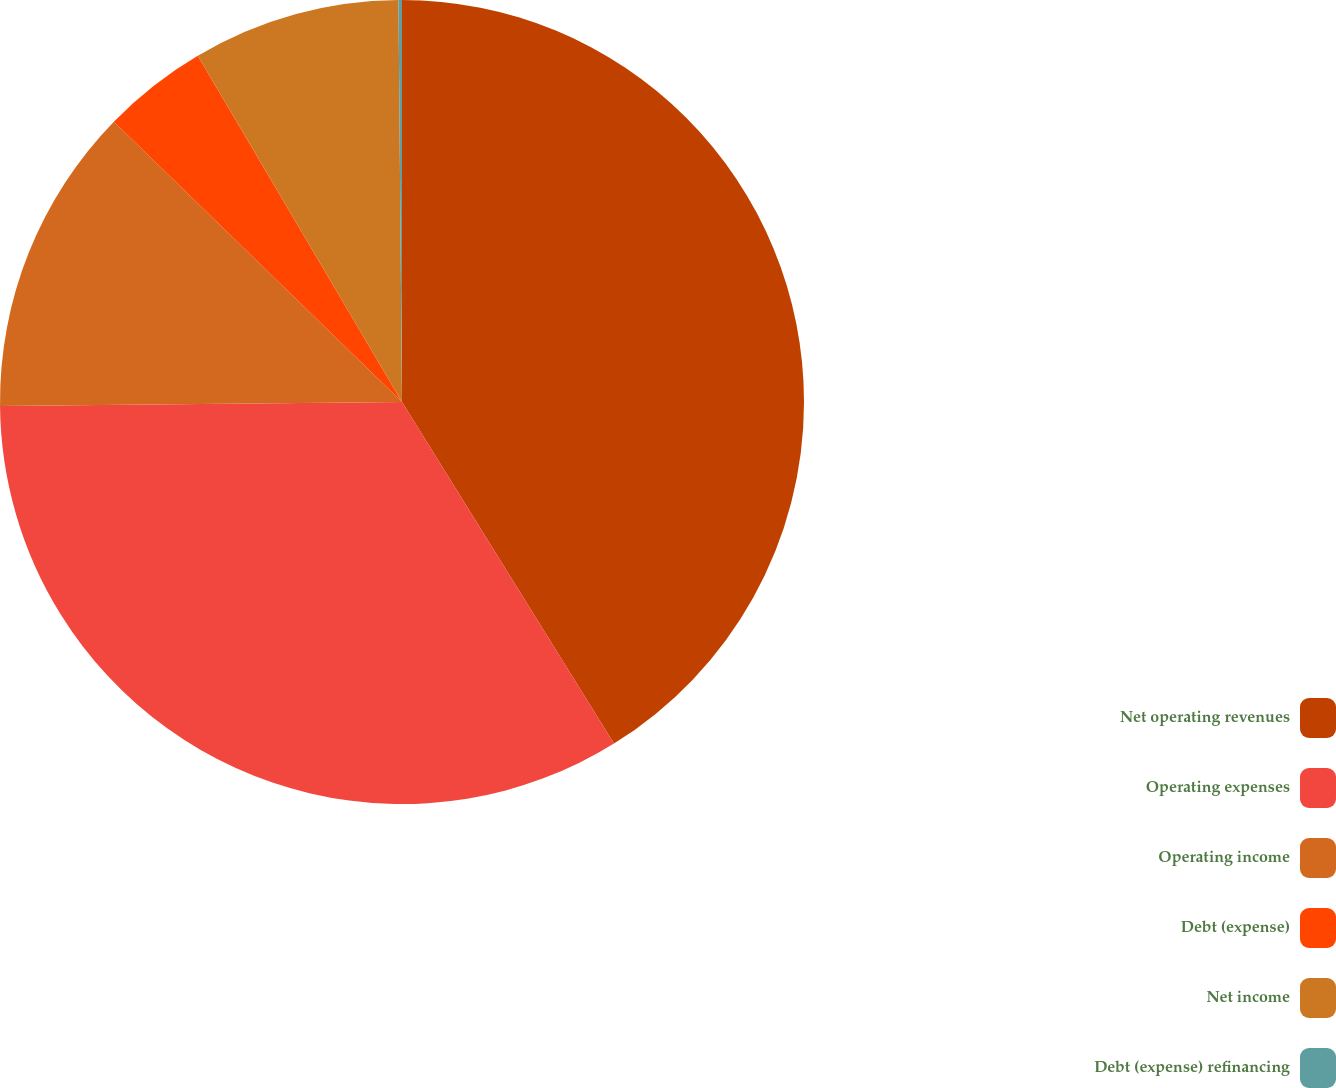Convert chart to OTSL. <chart><loc_0><loc_0><loc_500><loc_500><pie_chart><fcel>Net operating revenues<fcel>Operating expenses<fcel>Operating income<fcel>Debt (expense)<fcel>Net income<fcel>Debt (expense) refinancing<nl><fcel>41.16%<fcel>33.68%<fcel>12.44%<fcel>4.24%<fcel>8.34%<fcel>0.14%<nl></chart> 